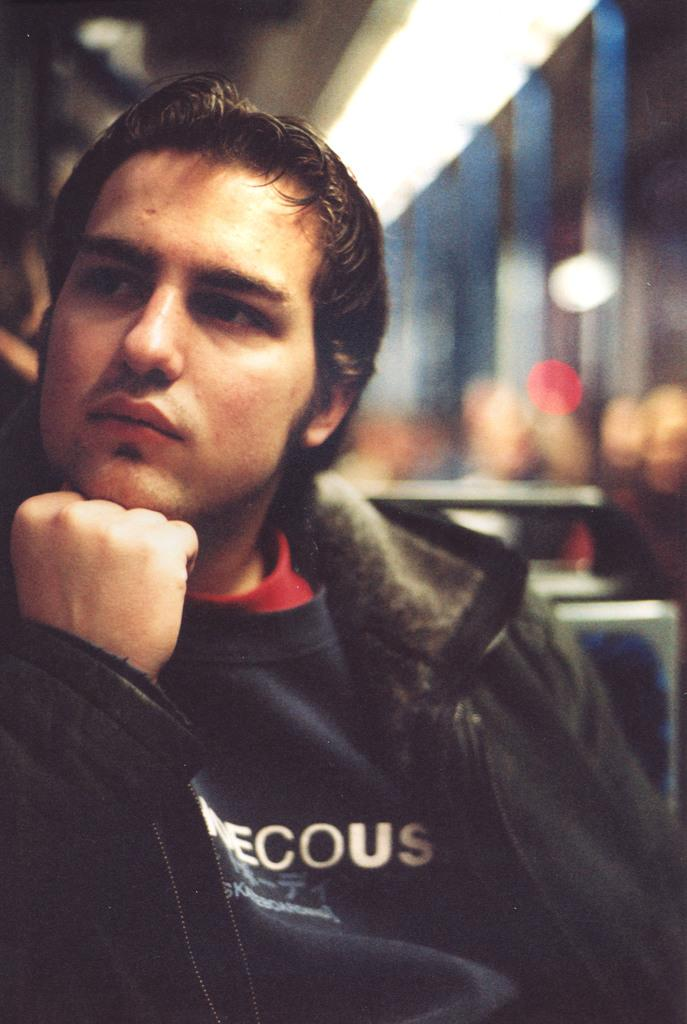Who is present in the image? There is a man in the image. What is the man doing in the image? The man is sitting on a chair. Can you describe the background of the image? The background of the image is blurred. What type of education does the man have, as depicted in the image? There is no information about the man's education in the image. What kind of lumber is being used to construct the chair the man is sitting on? The image does not provide information about the materials used to construct the chair. 